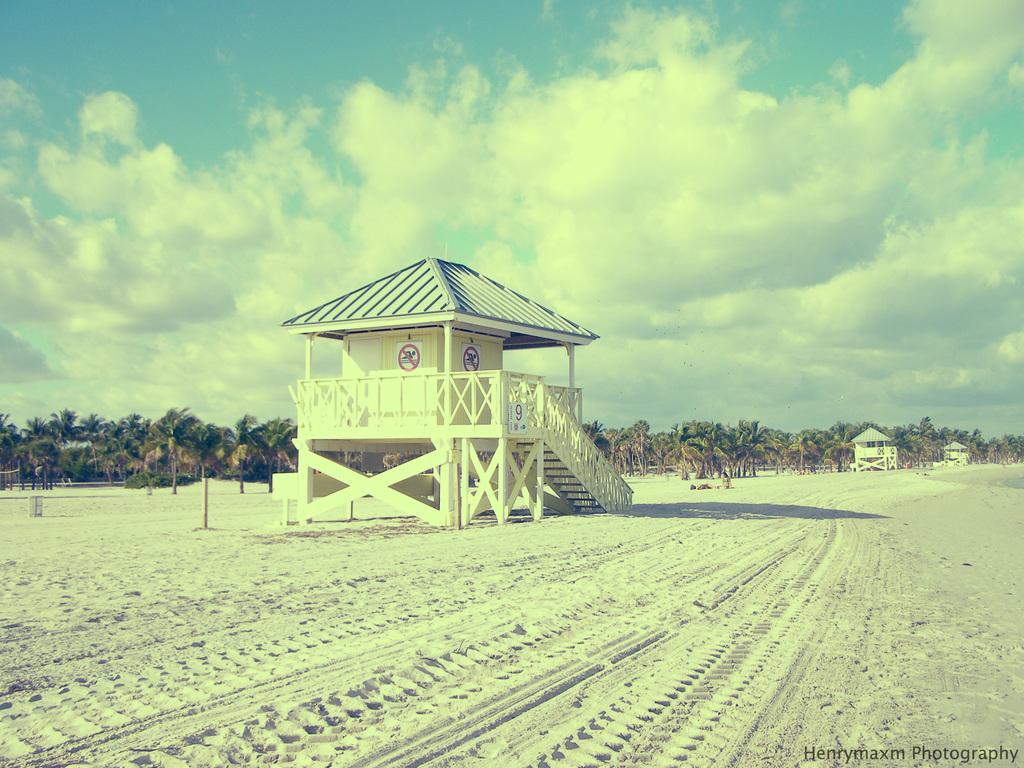How would you summarize this image in a sentence or two? In the picture we can see a white color sand and some tire marks with lines and some far from it, we can see a hut which are cream in color and behind it, we can see trees and in the background we can see a sky with clouds. 